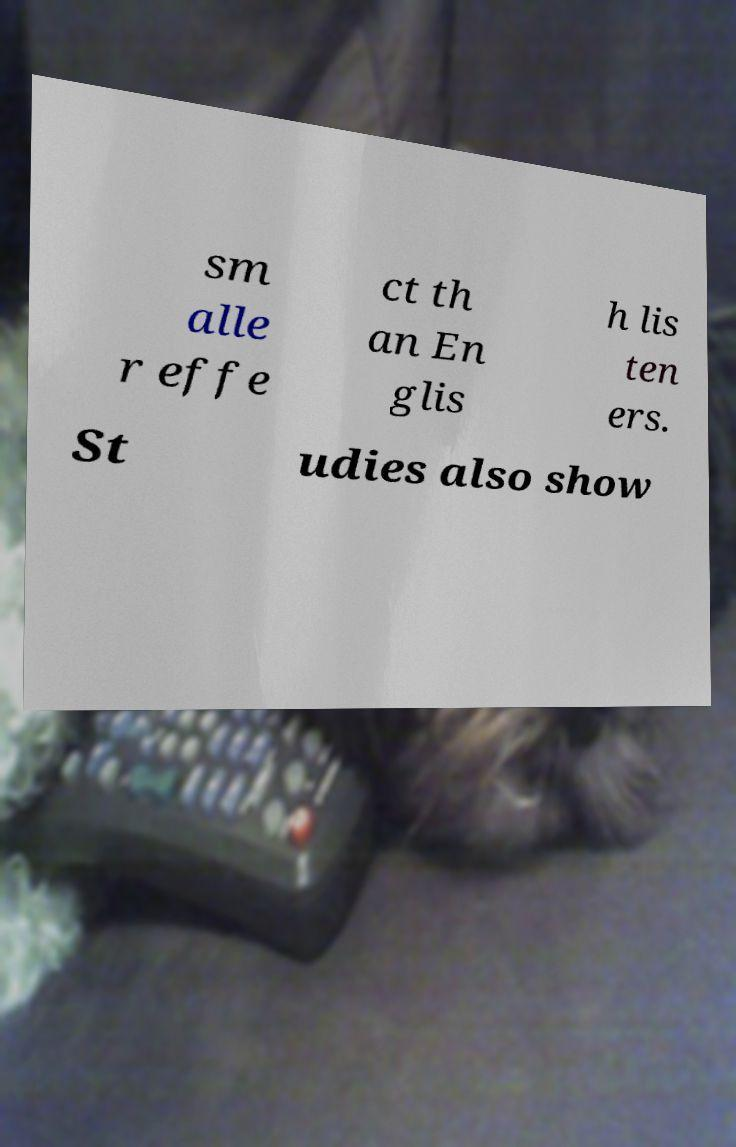Can you accurately transcribe the text from the provided image for me? sm alle r effe ct th an En glis h lis ten ers. St udies also show 